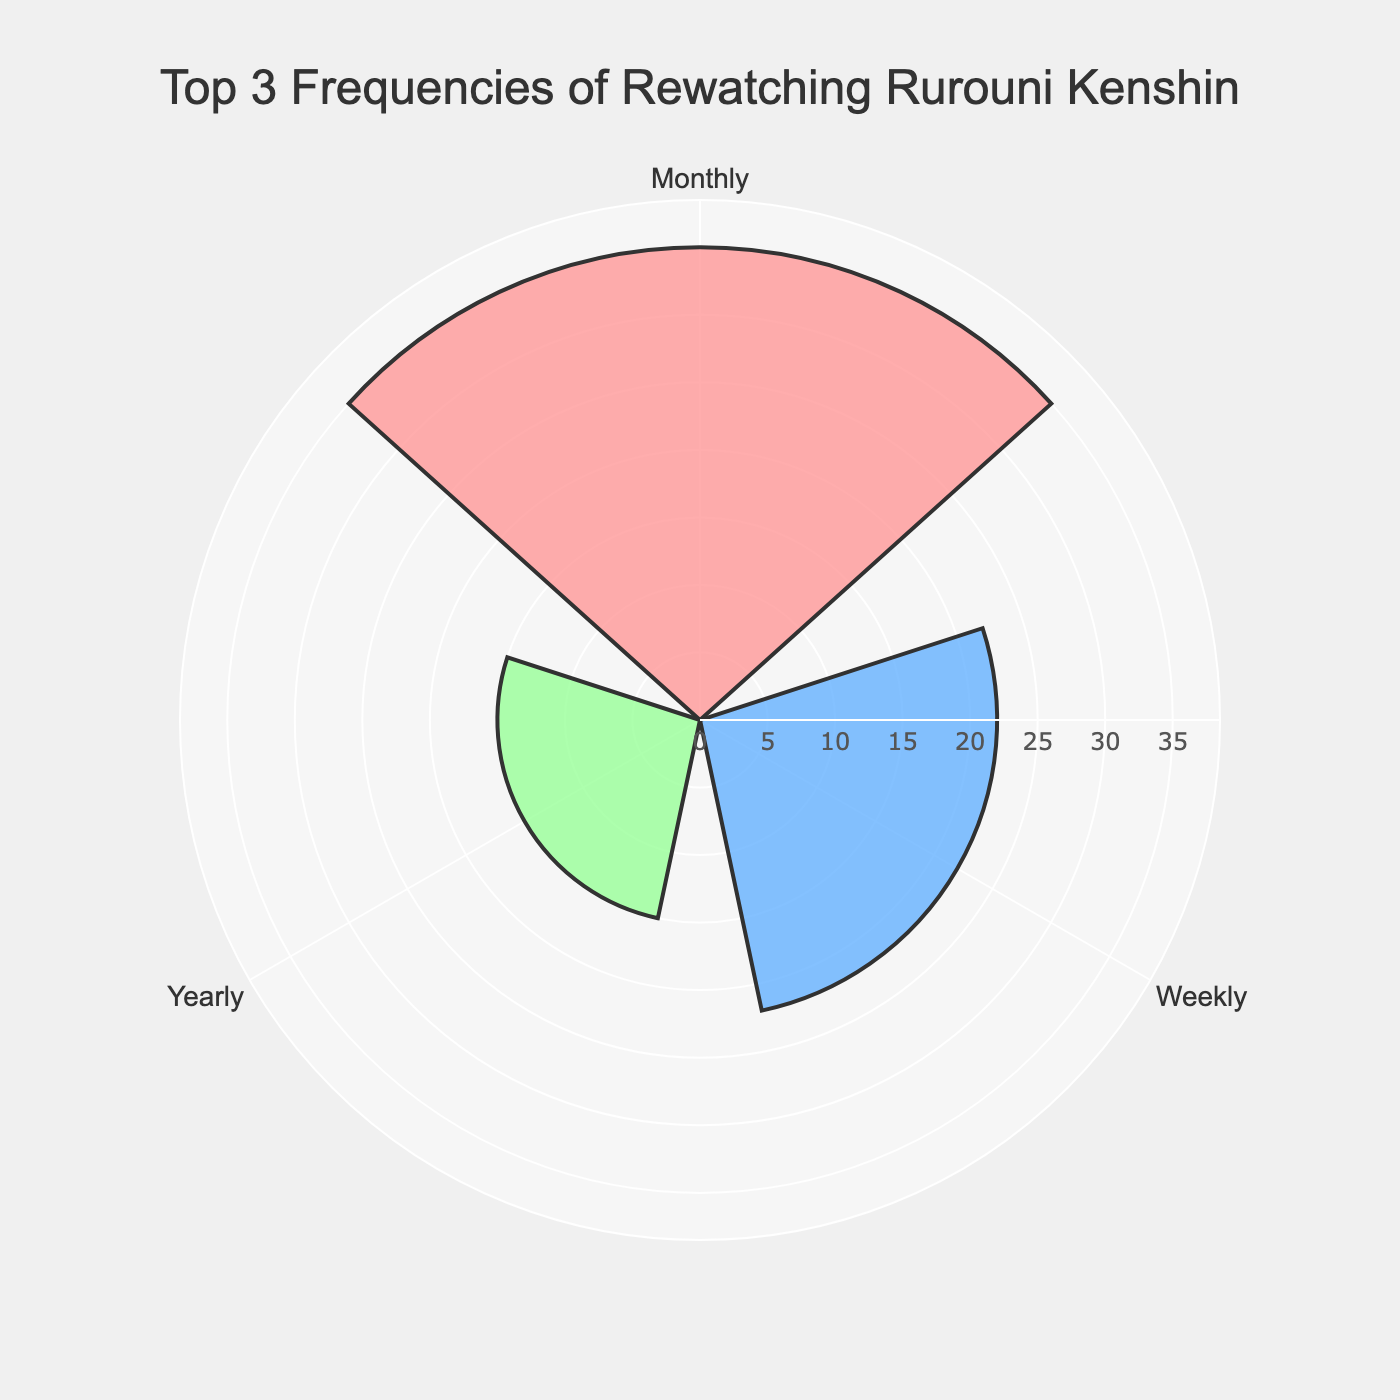What is the title of the rose chart? The title is usually located at the top of the plot. In this case, the title specifies the main subject of the data visualized.
Answer: Top 3 Frequencies of Rewatching Rurouni Kenshin Which group has the highest frequency? By comparing the lengths of the bars, the group with the longest bar has the highest frequency.
Answer: Monthly What is the frequency value for the 'Weekly' group? Locate the 'Weekly' group in the chart and read the corresponding frequency value.
Answer: 22 Among the top 3 frequencies, which group has the lowest frequency? Compare the lengths of the bars for the top 3 groups; the shortest one has the lowest frequency.
Answer: Yearly How much greater is the 'Monthly' frequency compared to 'Yearly'? Subtract the 'Yearly' frequency from the 'Monthly' frequency.
Answer: 35 - 15 = 20 What colors represent each of the groups in the chart? Identify the colors associated with the bars corresponding to each group. Monthly is the lightest color, Weekly is the medium blue, and Yearly is the light green.
Answer: Monthly: pink, Weekly: blue, Yearly: green Which group is plotted at the top position in the rose chart? Check the orientation of the bars to see which group is placed at the top angle.
Answer: Monthly What is the average frequency of the top 3 groups? Sum the frequency values for Monthly, Weekly, and Yearly, and then divide by the number of groups (3).
Answer: (35 + 22 + 15) / 3 = 24 Which direction does the angular axis rotate in the rose chart? The angular rotations are specified in the plot layout details. Look at the labels and their placements for clues.
Answer: Clockwise What is the total frequency of rewatching among the top 3 groups? Add the frequency values of the top 3 groups together.
Answer: 35 + 22 + 15 = 72 